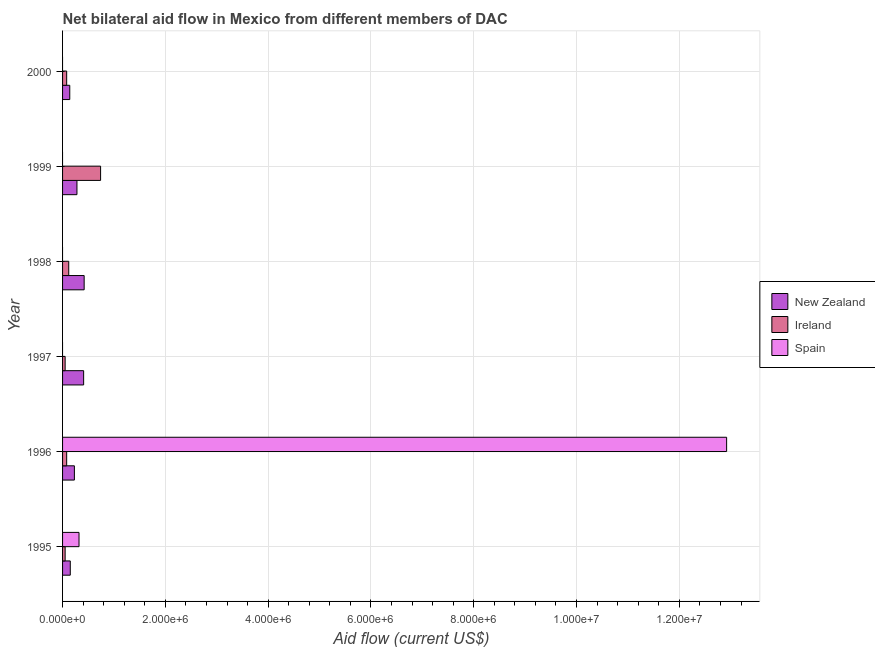How many different coloured bars are there?
Give a very brief answer. 3. Are the number of bars per tick equal to the number of legend labels?
Your response must be concise. No. Are the number of bars on each tick of the Y-axis equal?
Your answer should be compact. No. What is the amount of aid provided by ireland in 1996?
Your answer should be very brief. 8.00e+04. Across all years, what is the maximum amount of aid provided by new zealand?
Offer a terse response. 4.20e+05. Across all years, what is the minimum amount of aid provided by new zealand?
Offer a very short reply. 1.40e+05. What is the total amount of aid provided by ireland in the graph?
Offer a terse response. 1.12e+06. What is the difference between the amount of aid provided by ireland in 2000 and the amount of aid provided by spain in 1995?
Offer a terse response. -2.40e+05. What is the average amount of aid provided by spain per year?
Ensure brevity in your answer.  2.21e+06. In the year 1995, what is the difference between the amount of aid provided by ireland and amount of aid provided by spain?
Your response must be concise. -2.70e+05. What is the ratio of the amount of aid provided by new zealand in 1998 to that in 1999?
Provide a short and direct response. 1.5. Is the amount of aid provided by ireland in 1999 less than that in 2000?
Offer a terse response. No. Is the difference between the amount of aid provided by new zealand in 1996 and 1998 greater than the difference between the amount of aid provided by ireland in 1996 and 1998?
Your answer should be compact. No. What is the difference between the highest and the second highest amount of aid provided by ireland?
Provide a succinct answer. 6.20e+05. What is the difference between the highest and the lowest amount of aid provided by spain?
Provide a succinct answer. 1.29e+07. How many bars are there?
Give a very brief answer. 14. Are all the bars in the graph horizontal?
Ensure brevity in your answer.  Yes. Are the values on the major ticks of X-axis written in scientific E-notation?
Provide a short and direct response. Yes. Does the graph contain any zero values?
Your answer should be compact. Yes. Where does the legend appear in the graph?
Your answer should be compact. Center right. How many legend labels are there?
Make the answer very short. 3. What is the title of the graph?
Provide a short and direct response. Net bilateral aid flow in Mexico from different members of DAC. Does "Coal sources" appear as one of the legend labels in the graph?
Ensure brevity in your answer.  No. What is the Aid flow (current US$) of New Zealand in 1995?
Keep it short and to the point. 1.50e+05. What is the Aid flow (current US$) in New Zealand in 1996?
Keep it short and to the point. 2.30e+05. What is the Aid flow (current US$) in Spain in 1996?
Your response must be concise. 1.29e+07. What is the Aid flow (current US$) of New Zealand in 1997?
Provide a succinct answer. 4.10e+05. What is the Aid flow (current US$) in Ireland in 1997?
Offer a very short reply. 5.00e+04. What is the Aid flow (current US$) in Spain in 1998?
Your answer should be compact. 0. What is the Aid flow (current US$) in Ireland in 1999?
Offer a terse response. 7.40e+05. What is the Aid flow (current US$) of Spain in 2000?
Provide a succinct answer. 0. Across all years, what is the maximum Aid flow (current US$) of Ireland?
Keep it short and to the point. 7.40e+05. Across all years, what is the maximum Aid flow (current US$) of Spain?
Your answer should be compact. 1.29e+07. Across all years, what is the minimum Aid flow (current US$) of Ireland?
Offer a very short reply. 5.00e+04. Across all years, what is the minimum Aid flow (current US$) of Spain?
Keep it short and to the point. 0. What is the total Aid flow (current US$) in New Zealand in the graph?
Provide a succinct answer. 1.63e+06. What is the total Aid flow (current US$) in Ireland in the graph?
Give a very brief answer. 1.12e+06. What is the total Aid flow (current US$) in Spain in the graph?
Your answer should be compact. 1.32e+07. What is the difference between the Aid flow (current US$) in New Zealand in 1995 and that in 1996?
Offer a very short reply. -8.00e+04. What is the difference between the Aid flow (current US$) of Ireland in 1995 and that in 1996?
Your answer should be very brief. -3.00e+04. What is the difference between the Aid flow (current US$) in Spain in 1995 and that in 1996?
Keep it short and to the point. -1.26e+07. What is the difference between the Aid flow (current US$) of New Zealand in 1995 and that in 1998?
Provide a short and direct response. -2.70e+05. What is the difference between the Aid flow (current US$) of Ireland in 1995 and that in 1998?
Provide a succinct answer. -7.00e+04. What is the difference between the Aid flow (current US$) of Ireland in 1995 and that in 1999?
Your answer should be compact. -6.90e+05. What is the difference between the Aid flow (current US$) in Ireland in 1995 and that in 2000?
Provide a succinct answer. -3.00e+04. What is the difference between the Aid flow (current US$) in New Zealand in 1996 and that in 1999?
Provide a succinct answer. -5.00e+04. What is the difference between the Aid flow (current US$) in Ireland in 1996 and that in 1999?
Provide a succinct answer. -6.60e+05. What is the difference between the Aid flow (current US$) in New Zealand in 1996 and that in 2000?
Your response must be concise. 9.00e+04. What is the difference between the Aid flow (current US$) in New Zealand in 1997 and that in 1999?
Keep it short and to the point. 1.30e+05. What is the difference between the Aid flow (current US$) of Ireland in 1997 and that in 1999?
Your answer should be very brief. -6.90e+05. What is the difference between the Aid flow (current US$) in Ireland in 1998 and that in 1999?
Provide a short and direct response. -6.20e+05. What is the difference between the Aid flow (current US$) in New Zealand in 1998 and that in 2000?
Offer a very short reply. 2.80e+05. What is the difference between the Aid flow (current US$) of Ireland in 1998 and that in 2000?
Provide a succinct answer. 4.00e+04. What is the difference between the Aid flow (current US$) in New Zealand in 1995 and the Aid flow (current US$) in Spain in 1996?
Make the answer very short. -1.28e+07. What is the difference between the Aid flow (current US$) of Ireland in 1995 and the Aid flow (current US$) of Spain in 1996?
Keep it short and to the point. -1.29e+07. What is the difference between the Aid flow (current US$) of New Zealand in 1995 and the Aid flow (current US$) of Ireland in 1999?
Offer a terse response. -5.90e+05. What is the difference between the Aid flow (current US$) in New Zealand in 1996 and the Aid flow (current US$) in Ireland in 1997?
Your answer should be compact. 1.80e+05. What is the difference between the Aid flow (current US$) of New Zealand in 1996 and the Aid flow (current US$) of Ireland in 1998?
Your response must be concise. 1.10e+05. What is the difference between the Aid flow (current US$) in New Zealand in 1996 and the Aid flow (current US$) in Ireland in 1999?
Provide a short and direct response. -5.10e+05. What is the difference between the Aid flow (current US$) of New Zealand in 1996 and the Aid flow (current US$) of Ireland in 2000?
Your answer should be compact. 1.50e+05. What is the difference between the Aid flow (current US$) of New Zealand in 1997 and the Aid flow (current US$) of Ireland in 1998?
Provide a succinct answer. 2.90e+05. What is the difference between the Aid flow (current US$) in New Zealand in 1997 and the Aid flow (current US$) in Ireland in 1999?
Your answer should be very brief. -3.30e+05. What is the difference between the Aid flow (current US$) of New Zealand in 1997 and the Aid flow (current US$) of Ireland in 2000?
Offer a very short reply. 3.30e+05. What is the difference between the Aid flow (current US$) of New Zealand in 1998 and the Aid flow (current US$) of Ireland in 1999?
Make the answer very short. -3.20e+05. What is the difference between the Aid flow (current US$) in New Zealand in 1999 and the Aid flow (current US$) in Ireland in 2000?
Make the answer very short. 2.00e+05. What is the average Aid flow (current US$) of New Zealand per year?
Provide a short and direct response. 2.72e+05. What is the average Aid flow (current US$) of Ireland per year?
Your answer should be compact. 1.87e+05. What is the average Aid flow (current US$) of Spain per year?
Your response must be concise. 2.21e+06. In the year 1995, what is the difference between the Aid flow (current US$) in New Zealand and Aid flow (current US$) in Spain?
Ensure brevity in your answer.  -1.70e+05. In the year 1996, what is the difference between the Aid flow (current US$) of New Zealand and Aid flow (current US$) of Spain?
Give a very brief answer. -1.27e+07. In the year 1996, what is the difference between the Aid flow (current US$) of Ireland and Aid flow (current US$) of Spain?
Your answer should be very brief. -1.28e+07. In the year 1997, what is the difference between the Aid flow (current US$) of New Zealand and Aid flow (current US$) of Ireland?
Ensure brevity in your answer.  3.60e+05. In the year 1999, what is the difference between the Aid flow (current US$) in New Zealand and Aid flow (current US$) in Ireland?
Offer a very short reply. -4.60e+05. What is the ratio of the Aid flow (current US$) in New Zealand in 1995 to that in 1996?
Offer a very short reply. 0.65. What is the ratio of the Aid flow (current US$) in Spain in 1995 to that in 1996?
Your answer should be very brief. 0.02. What is the ratio of the Aid flow (current US$) of New Zealand in 1995 to that in 1997?
Your answer should be compact. 0.37. What is the ratio of the Aid flow (current US$) in New Zealand in 1995 to that in 1998?
Offer a very short reply. 0.36. What is the ratio of the Aid flow (current US$) in Ireland in 1995 to that in 1998?
Ensure brevity in your answer.  0.42. What is the ratio of the Aid flow (current US$) of New Zealand in 1995 to that in 1999?
Keep it short and to the point. 0.54. What is the ratio of the Aid flow (current US$) of Ireland in 1995 to that in 1999?
Ensure brevity in your answer.  0.07. What is the ratio of the Aid flow (current US$) of New Zealand in 1995 to that in 2000?
Give a very brief answer. 1.07. What is the ratio of the Aid flow (current US$) of New Zealand in 1996 to that in 1997?
Ensure brevity in your answer.  0.56. What is the ratio of the Aid flow (current US$) in Ireland in 1996 to that in 1997?
Ensure brevity in your answer.  1.6. What is the ratio of the Aid flow (current US$) of New Zealand in 1996 to that in 1998?
Offer a very short reply. 0.55. What is the ratio of the Aid flow (current US$) in New Zealand in 1996 to that in 1999?
Provide a succinct answer. 0.82. What is the ratio of the Aid flow (current US$) of Ireland in 1996 to that in 1999?
Give a very brief answer. 0.11. What is the ratio of the Aid flow (current US$) of New Zealand in 1996 to that in 2000?
Keep it short and to the point. 1.64. What is the ratio of the Aid flow (current US$) of Ireland in 1996 to that in 2000?
Offer a terse response. 1. What is the ratio of the Aid flow (current US$) in New Zealand in 1997 to that in 1998?
Keep it short and to the point. 0.98. What is the ratio of the Aid flow (current US$) of Ireland in 1997 to that in 1998?
Ensure brevity in your answer.  0.42. What is the ratio of the Aid flow (current US$) of New Zealand in 1997 to that in 1999?
Provide a succinct answer. 1.46. What is the ratio of the Aid flow (current US$) of Ireland in 1997 to that in 1999?
Give a very brief answer. 0.07. What is the ratio of the Aid flow (current US$) of New Zealand in 1997 to that in 2000?
Give a very brief answer. 2.93. What is the ratio of the Aid flow (current US$) of Ireland in 1998 to that in 1999?
Offer a terse response. 0.16. What is the ratio of the Aid flow (current US$) of New Zealand in 1999 to that in 2000?
Your answer should be compact. 2. What is the ratio of the Aid flow (current US$) in Ireland in 1999 to that in 2000?
Provide a succinct answer. 9.25. What is the difference between the highest and the second highest Aid flow (current US$) of New Zealand?
Your response must be concise. 10000. What is the difference between the highest and the second highest Aid flow (current US$) of Ireland?
Your answer should be very brief. 6.20e+05. What is the difference between the highest and the lowest Aid flow (current US$) in New Zealand?
Your answer should be very brief. 2.80e+05. What is the difference between the highest and the lowest Aid flow (current US$) in Ireland?
Offer a very short reply. 6.90e+05. What is the difference between the highest and the lowest Aid flow (current US$) of Spain?
Make the answer very short. 1.29e+07. 